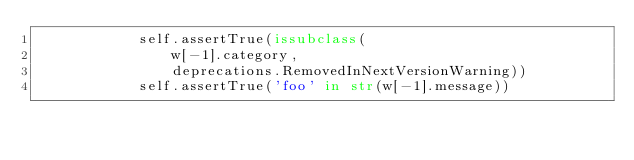<code> <loc_0><loc_0><loc_500><loc_500><_Python_>            self.assertTrue(issubclass(
                w[-1].category,
                deprecations.RemovedInNextVersionWarning))
            self.assertTrue('foo' in str(w[-1].message))
</code> 